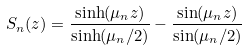Convert formula to latex. <formula><loc_0><loc_0><loc_500><loc_500>S _ { n } ( z ) = \frac { \sinh ( \mu _ { n } z ) } { \sinh ( \mu _ { n } / 2 ) } - \frac { \sin ( \mu _ { n } z ) } { \sin ( \mu _ { n } / 2 ) }</formula> 